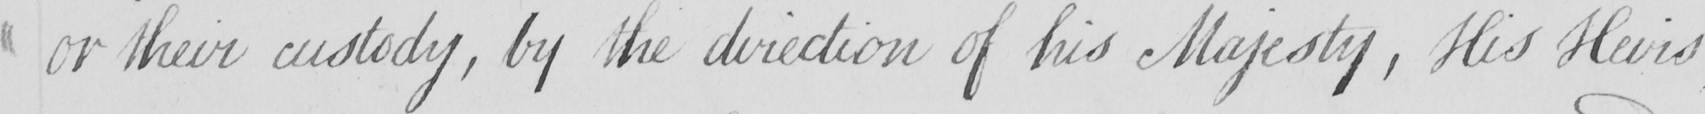What is written in this line of handwriting? or their custody , by the direction of his Majesty , His Heirs 